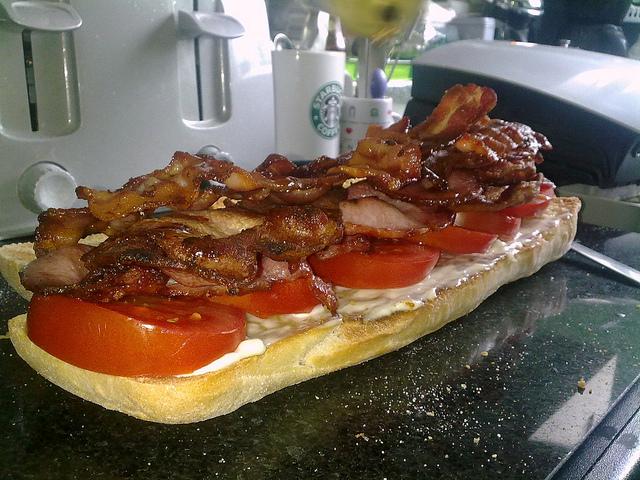What is the meat on the sandwich?
Be succinct. Bacon. Where are the tomatoes?
Write a very short answer. Under bacon. Does the bread appear toasted?
Write a very short answer. Yes. 